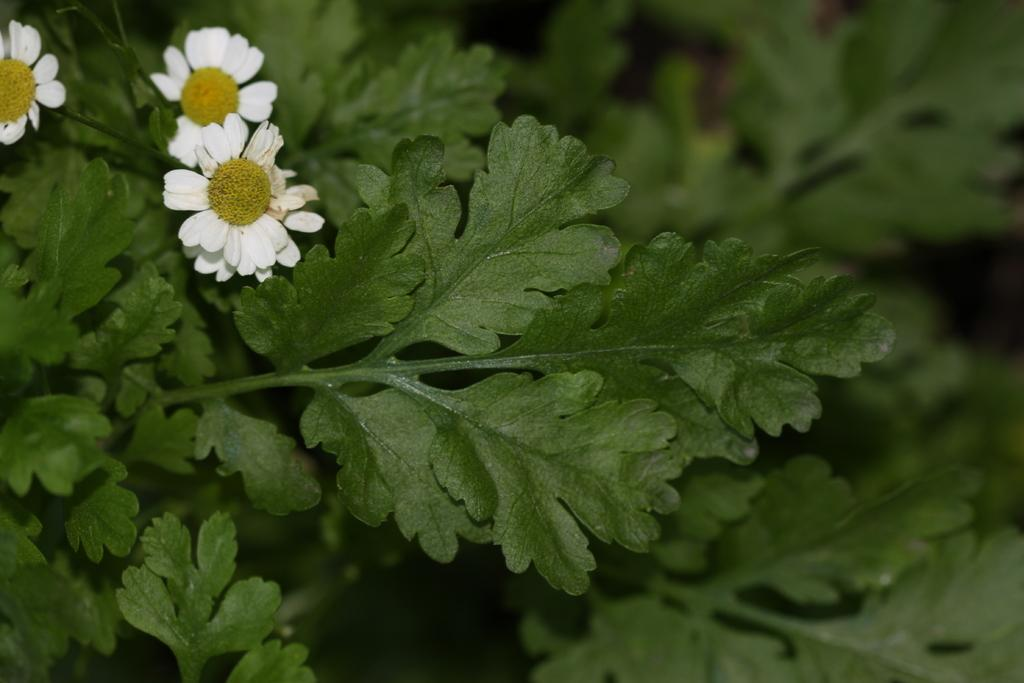What type of vegetation is present in the image? There are green leaves in the image. What color are the flowers in the image? There are white flowers in the image. How would you describe the quality of the background in the image? The image is blurry in the background. What type of kettle is visible on the floor in the image? There is no kettle present in the image, and the floor is not visible. 